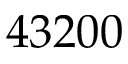<formula> <loc_0><loc_0><loc_500><loc_500>4 3 2 0 0</formula> 